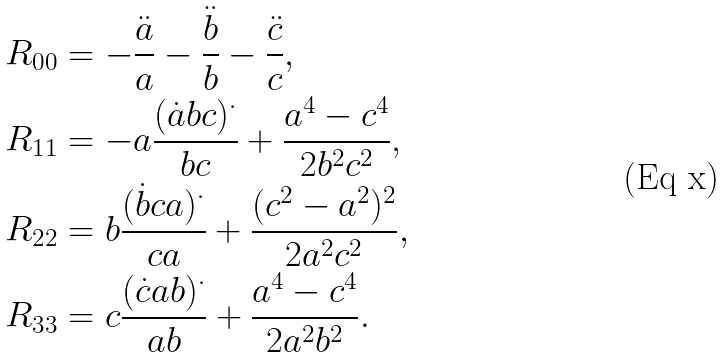<formula> <loc_0><loc_0><loc_500><loc_500>R _ { 0 0 } & = - \frac { \ddot { a } } { a } - \frac { \ddot { b } } { b } - \frac { \ddot { c } } { c } , \\ R _ { 1 1 } & = - a \frac { ( \dot { a } b c ) ^ { \cdot } } { b c } + \frac { a ^ { 4 } - c ^ { 4 } } { 2 b ^ { 2 } c ^ { 2 } } , \\ R _ { 2 2 } & = b \frac { ( \dot { b } c a ) ^ { \cdot } } { c a } + \frac { ( c ^ { 2 } - a ^ { 2 } ) ^ { 2 } } { 2 a ^ { 2 } c ^ { 2 } } , \\ R _ { 3 3 } & = c \frac { ( \dot { c } a b ) ^ { \cdot } } { a b } + \frac { a ^ { 4 } - c ^ { 4 } } { 2 a ^ { 2 } b ^ { 2 } } .</formula> 